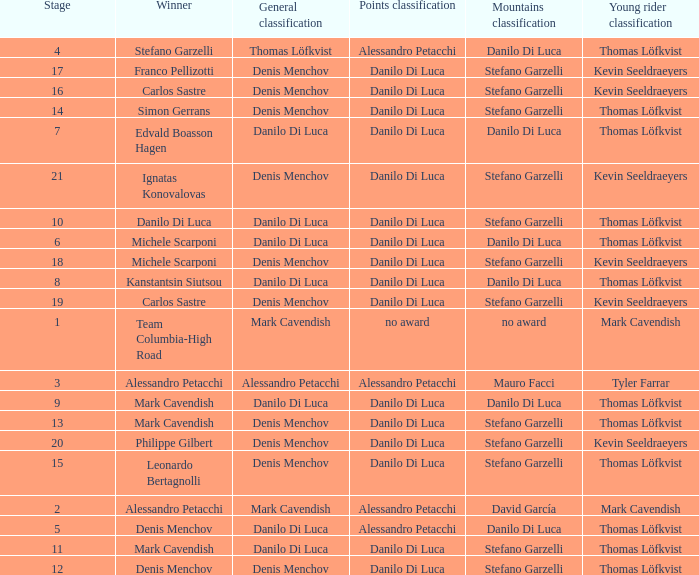When philippe gilbert is the winner who is the points classification? Danilo Di Luca. 